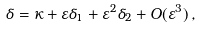Convert formula to latex. <formula><loc_0><loc_0><loc_500><loc_500>\delta = \kappa + \varepsilon \delta _ { 1 } + \varepsilon ^ { 2 } \delta _ { 2 } + O ( \varepsilon ^ { 3 } ) \, ,</formula> 